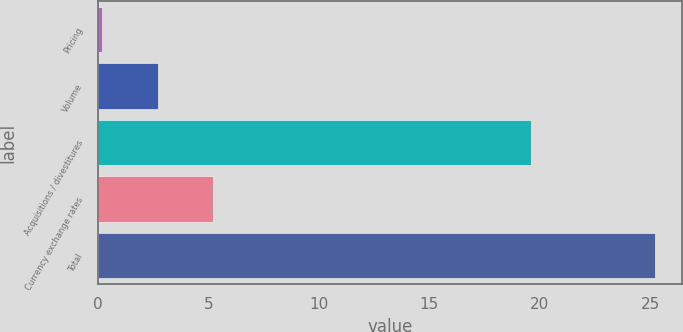Convert chart. <chart><loc_0><loc_0><loc_500><loc_500><bar_chart><fcel>Pricing<fcel>Volume<fcel>Acquisitions / divestitures<fcel>Currency exchange rates<fcel>Total<nl><fcel>0.2<fcel>2.7<fcel>19.6<fcel>5.2<fcel>25.2<nl></chart> 